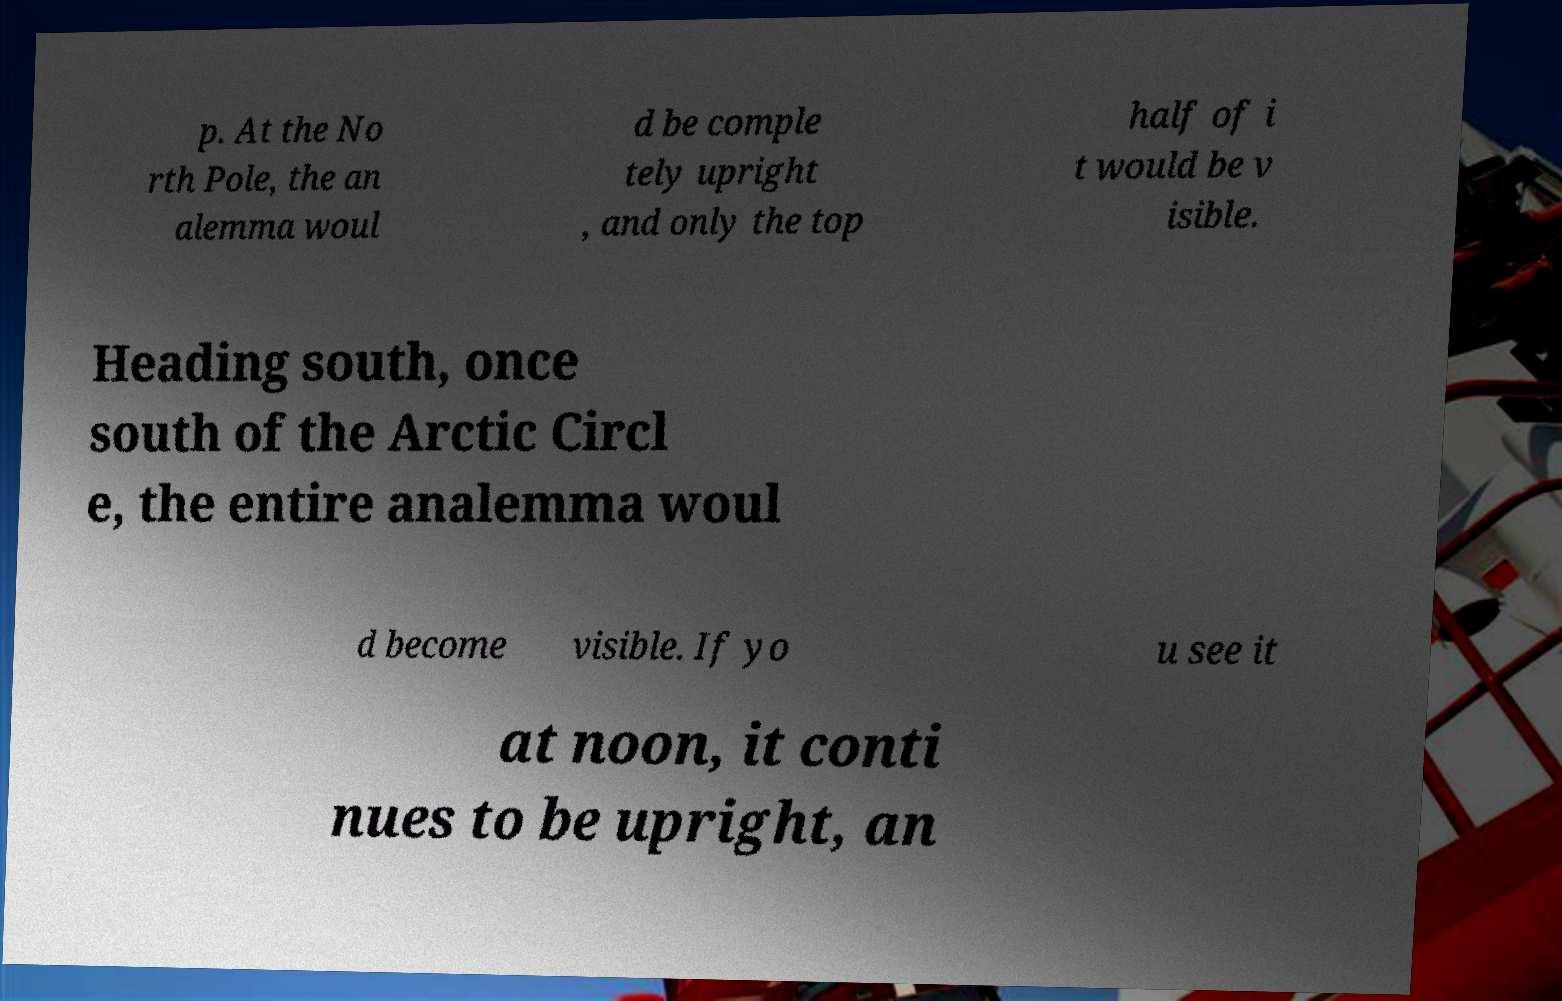For documentation purposes, I need the text within this image transcribed. Could you provide that? p. At the No rth Pole, the an alemma woul d be comple tely upright , and only the top half of i t would be v isible. Heading south, once south of the Arctic Circl e, the entire analemma woul d become visible. If yo u see it at noon, it conti nues to be upright, an 